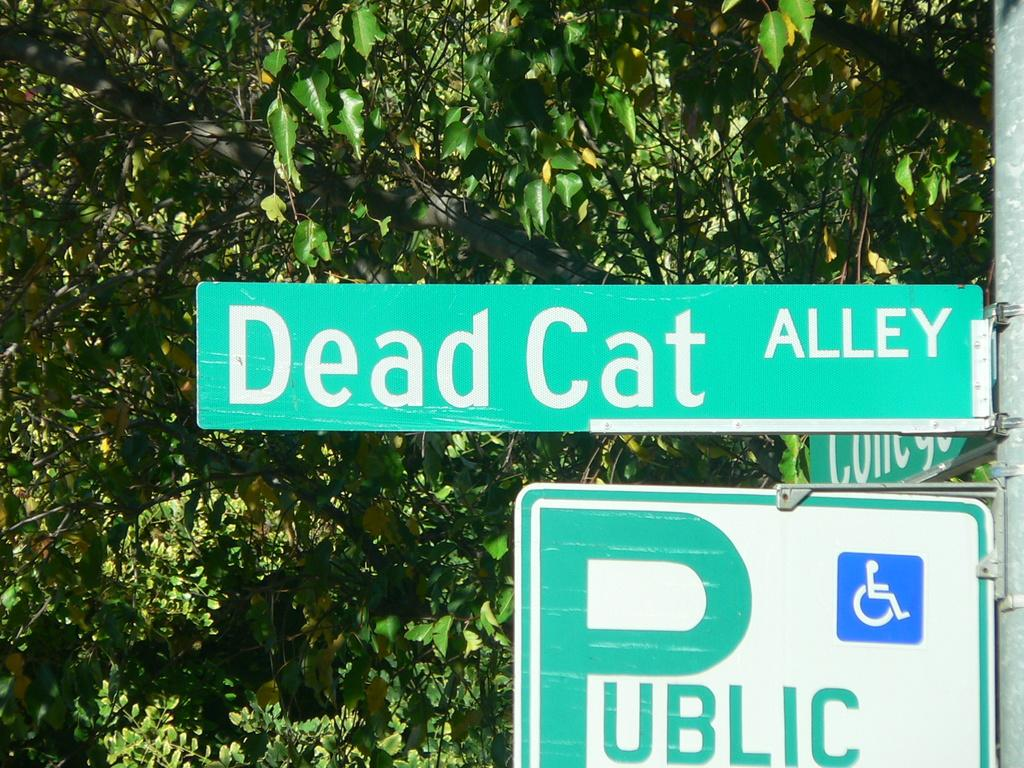<image>
Share a concise interpretation of the image provided. The name of the street is Dead Cat Alley. 